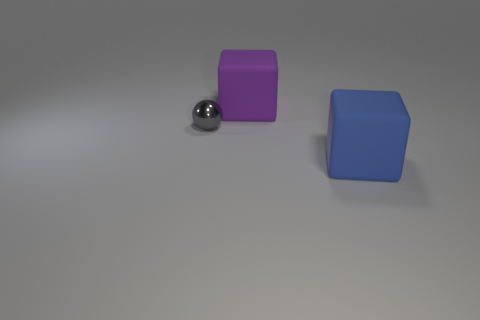Subtract all cubes. How many objects are left? 1 Add 2 large gray metallic things. How many objects exist? 5 Subtract 0 green blocks. How many objects are left? 3 Subtract all green cubes. Subtract all cyan balls. How many cubes are left? 2 Subtract all gray spheres. How many blue blocks are left? 1 Subtract all purple things. Subtract all large blue matte objects. How many objects are left? 1 Add 2 balls. How many balls are left? 3 Add 3 big matte blocks. How many big matte blocks exist? 5 